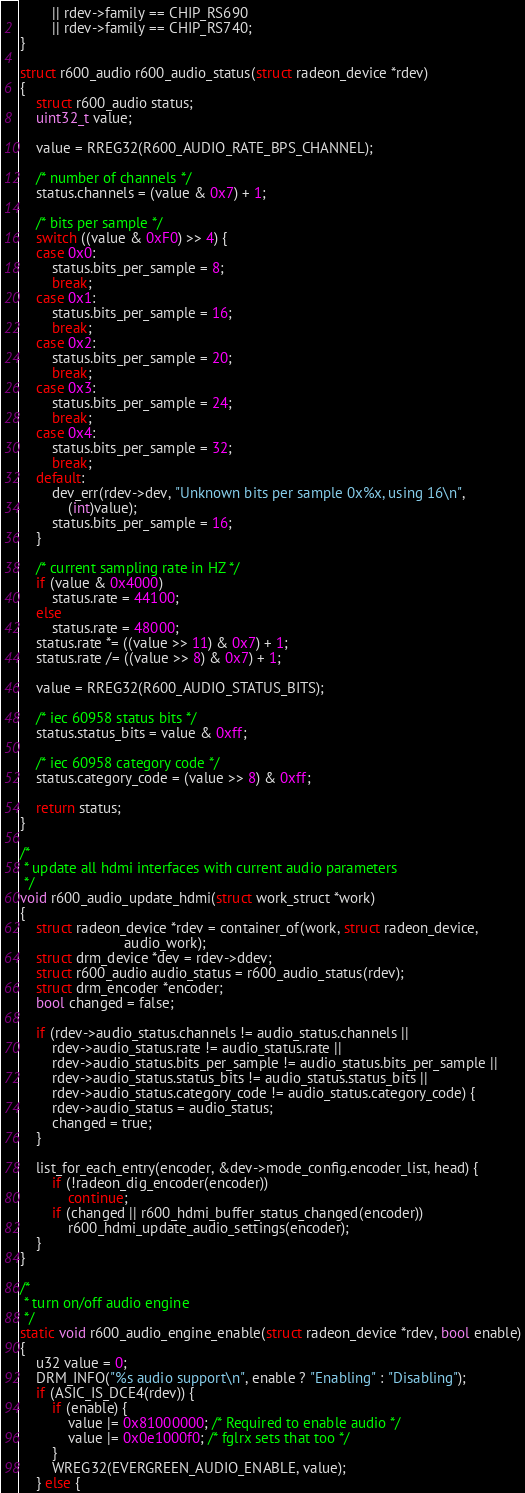<code> <loc_0><loc_0><loc_500><loc_500><_C_>		|| rdev->family == CHIP_RS690
		|| rdev->family == CHIP_RS740;
}

struct r600_audio r600_audio_status(struct radeon_device *rdev)
{
	struct r600_audio status;
	uint32_t value;

	value = RREG32(R600_AUDIO_RATE_BPS_CHANNEL);

	/* number of channels */
	status.channels = (value & 0x7) + 1;

	/* bits per sample */
	switch ((value & 0xF0) >> 4) {
	case 0x0:
		status.bits_per_sample = 8;
		break;
	case 0x1:
		status.bits_per_sample = 16;
		break;
	case 0x2:
		status.bits_per_sample = 20;
		break;
	case 0x3:
		status.bits_per_sample = 24;
		break;
	case 0x4:
		status.bits_per_sample = 32;
		break;
	default:
		dev_err(rdev->dev, "Unknown bits per sample 0x%x, using 16\n",
			(int)value);
		status.bits_per_sample = 16;
	}

	/* current sampling rate in HZ */
	if (value & 0x4000)
		status.rate = 44100;
	else
		status.rate = 48000;
	status.rate *= ((value >> 11) & 0x7) + 1;
	status.rate /= ((value >> 8) & 0x7) + 1;

	value = RREG32(R600_AUDIO_STATUS_BITS);

	/* iec 60958 status bits */
	status.status_bits = value & 0xff;

	/* iec 60958 category code */
	status.category_code = (value >> 8) & 0xff;

	return status;
}

/*
 * update all hdmi interfaces with current audio parameters
 */
void r600_audio_update_hdmi(struct work_struct *work)
{
	struct radeon_device *rdev = container_of(work, struct radeon_device,
						  audio_work);
	struct drm_device *dev = rdev->ddev;
	struct r600_audio audio_status = r600_audio_status(rdev);
	struct drm_encoder *encoder;
	bool changed = false;

	if (rdev->audio_status.channels != audio_status.channels ||
	    rdev->audio_status.rate != audio_status.rate ||
	    rdev->audio_status.bits_per_sample != audio_status.bits_per_sample ||
	    rdev->audio_status.status_bits != audio_status.status_bits ||
	    rdev->audio_status.category_code != audio_status.category_code) {
		rdev->audio_status = audio_status;
		changed = true;
	}

	list_for_each_entry(encoder, &dev->mode_config.encoder_list, head) {
		if (!radeon_dig_encoder(encoder))
			continue;
		if (changed || r600_hdmi_buffer_status_changed(encoder))
			r600_hdmi_update_audio_settings(encoder);
	}
}

/*
 * turn on/off audio engine
 */
static void r600_audio_engine_enable(struct radeon_device *rdev, bool enable)
{
	u32 value = 0;
	DRM_INFO("%s audio support\n", enable ? "Enabling" : "Disabling");
	if (ASIC_IS_DCE4(rdev)) {
		if (enable) {
			value |= 0x81000000; /* Required to enable audio */
			value |= 0x0e1000f0; /* fglrx sets that too */
		}
		WREG32(EVERGREEN_AUDIO_ENABLE, value);
	} else {</code> 